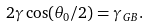<formula> <loc_0><loc_0><loc_500><loc_500>2 \gamma \cos ( \theta _ { 0 } / 2 ) = \gamma _ { G B } .</formula> 